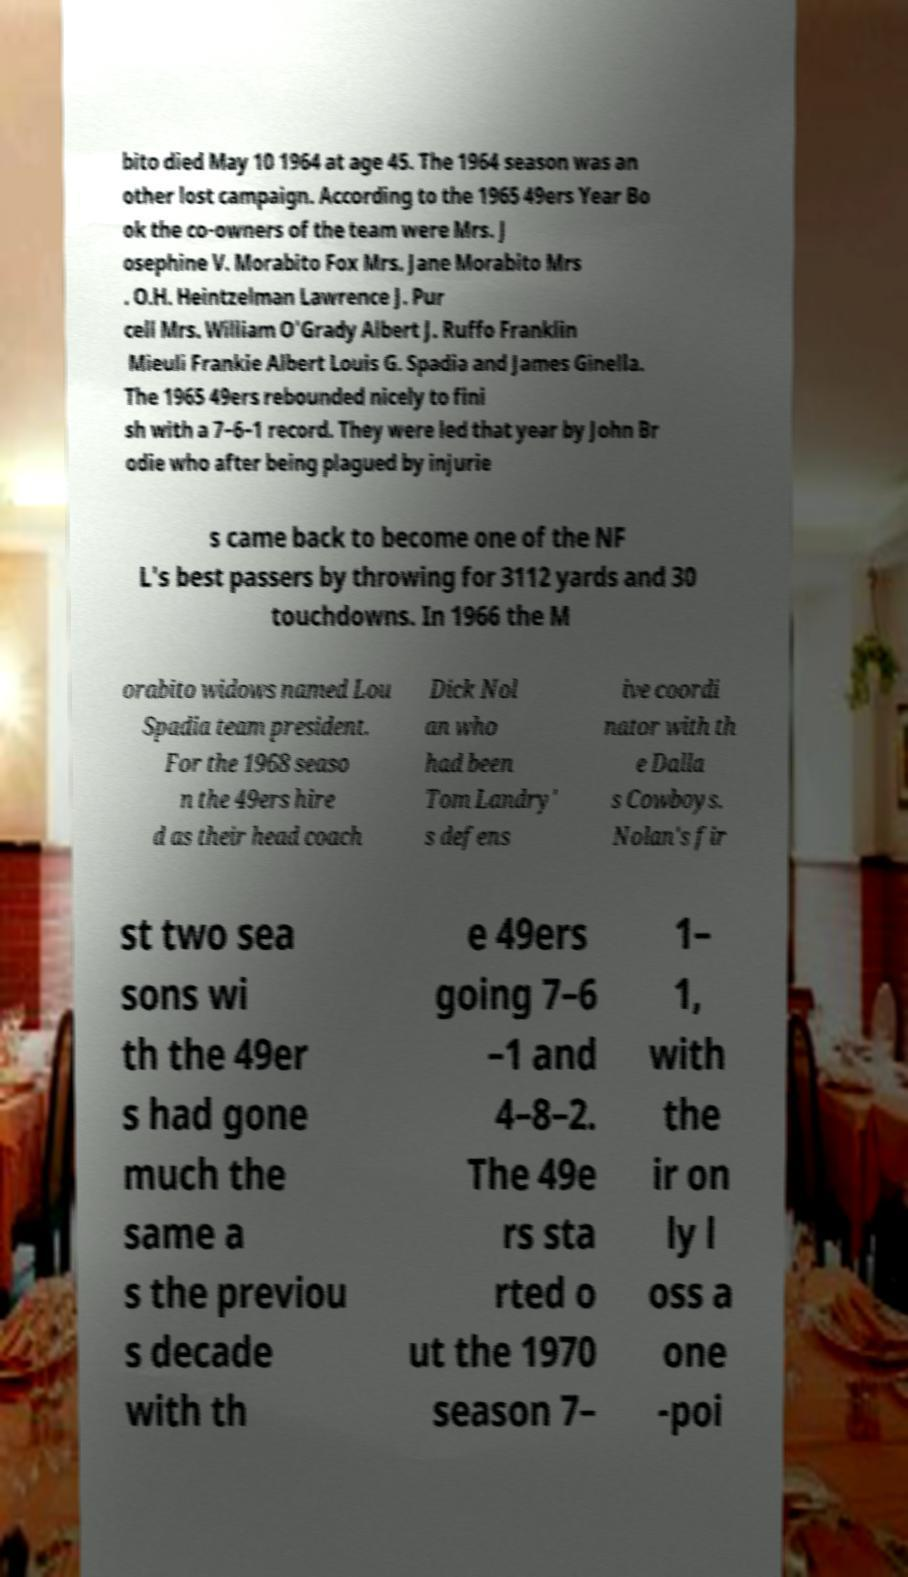Please read and relay the text visible in this image. What does it say? bito died May 10 1964 at age 45. The 1964 season was an other lost campaign. According to the 1965 49ers Year Bo ok the co-owners of the team were Mrs. J osephine V. Morabito Fox Mrs. Jane Morabito Mrs . O.H. Heintzelman Lawrence J. Pur cell Mrs. William O'Grady Albert J. Ruffo Franklin Mieuli Frankie Albert Louis G. Spadia and James Ginella. The 1965 49ers rebounded nicely to fini sh with a 7–6–1 record. They were led that year by John Br odie who after being plagued by injurie s came back to become one of the NF L's best passers by throwing for 3112 yards and 30 touchdowns. In 1966 the M orabito widows named Lou Spadia team president. For the 1968 seaso n the 49ers hire d as their head coach Dick Nol an who had been Tom Landry' s defens ive coordi nator with th e Dalla s Cowboys. Nolan's fir st two sea sons wi th the 49er s had gone much the same a s the previou s decade with th e 49ers going 7–6 –1 and 4–8–2. The 49e rs sta rted o ut the 1970 season 7– 1– 1, with the ir on ly l oss a one -poi 